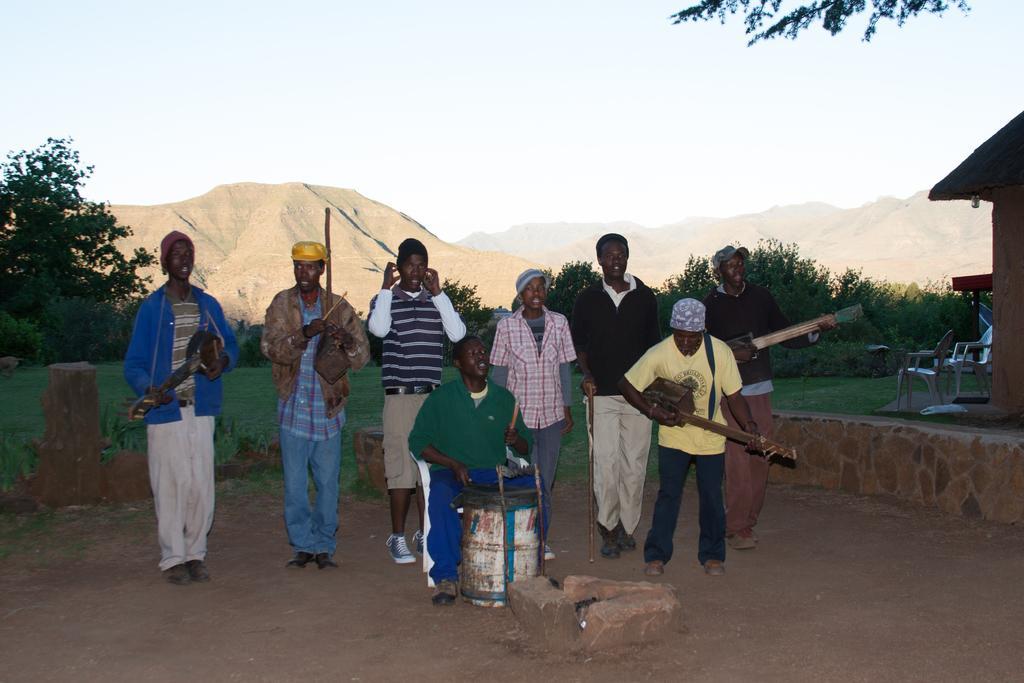Describe this image in one or two sentences. In this image we can see a few people holding the musical instruments, there are some trees, pillars, chairs, trees, grass and a house, in the background we can see the sky. 